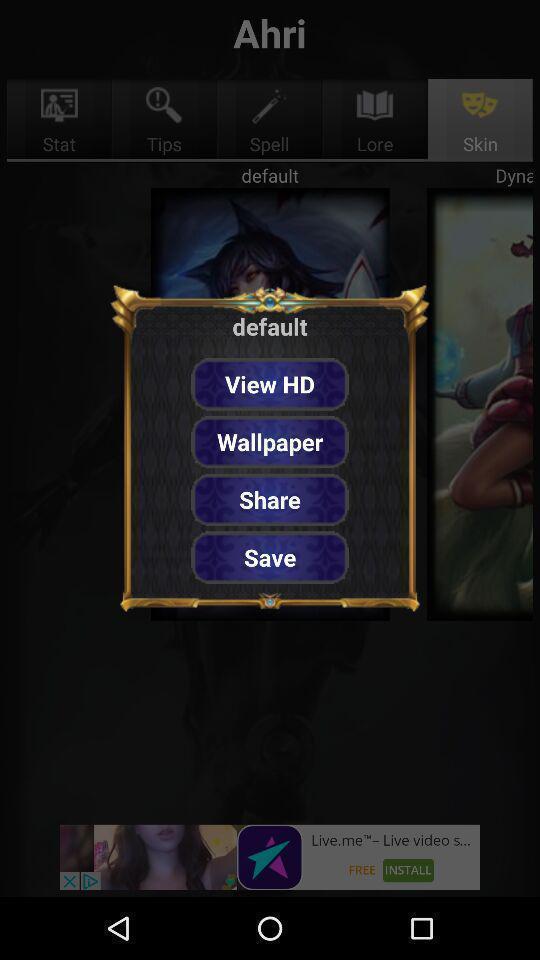Describe the visual elements of this screenshot. Pop up page showing various default for gaming app. 